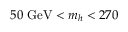Convert formula to latex. <formula><loc_0><loc_0><loc_500><loc_500>5 0 \ G e V < { m _ { h } } < 2 7 0</formula> 